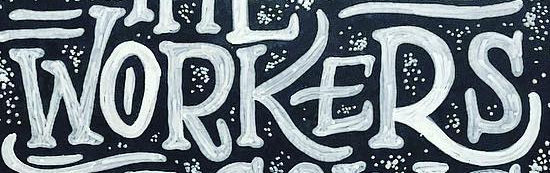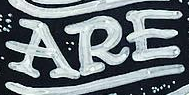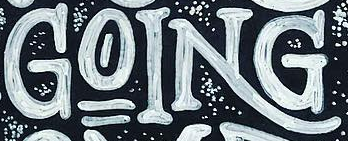What text is displayed in these images sequentially, separated by a semicolon? WORKERS; ARE; GOING 